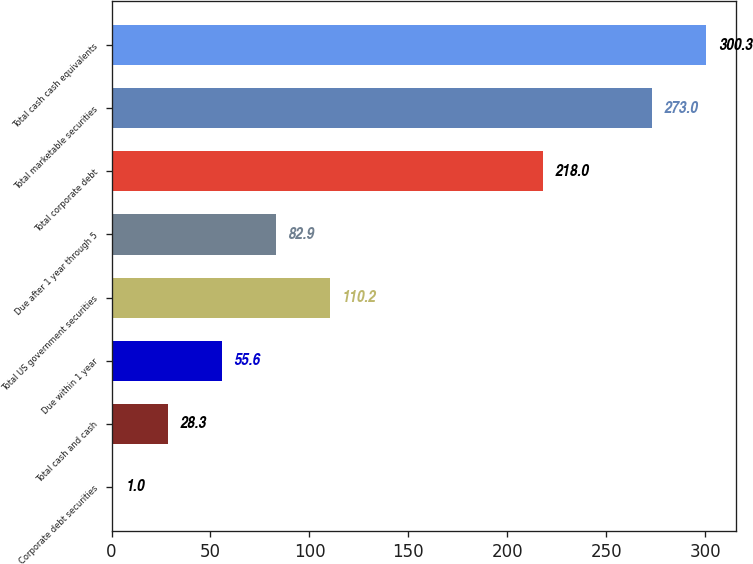<chart> <loc_0><loc_0><loc_500><loc_500><bar_chart><fcel>Corporate debt securities<fcel>Total cash and cash<fcel>Due within 1 year<fcel>Total US government securities<fcel>Due after 1 year through 5<fcel>Total corporate debt<fcel>Total marketable securities<fcel>Total cash cash equivalents<nl><fcel>1<fcel>28.3<fcel>55.6<fcel>110.2<fcel>82.9<fcel>218<fcel>273<fcel>300.3<nl></chart> 